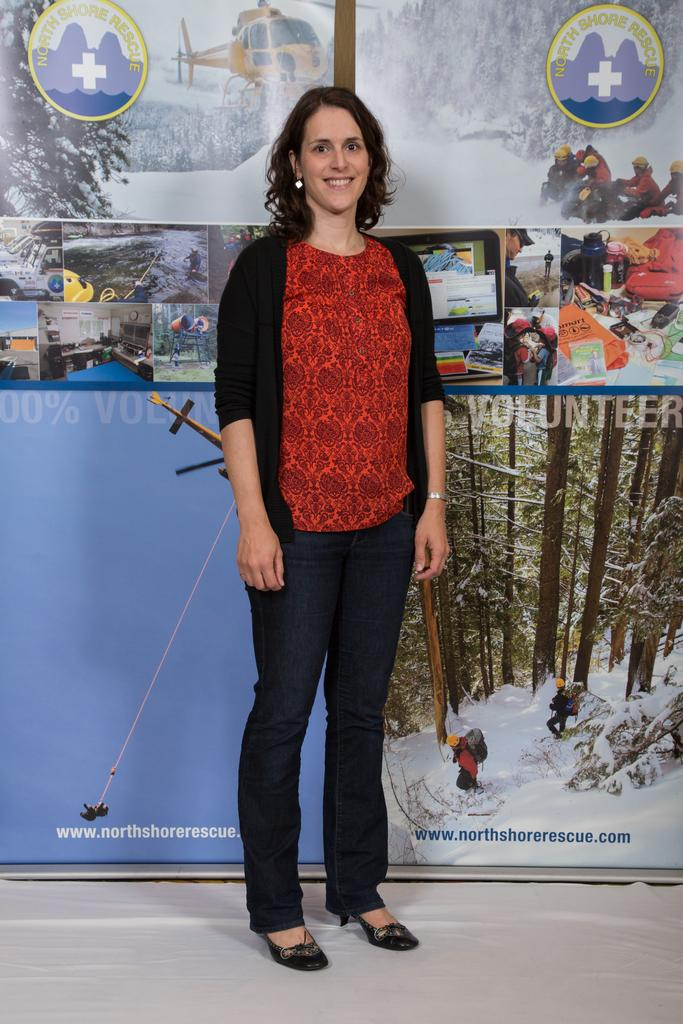What is the main subject in the foreground of the image? There is a woman standing in the foreground of the image. What is the woman standing on? The woman is standing on the ground. What can be seen in the background of the image? There is a banner, a group of people, trees, a helicopter, and the sky visible in the background of the image. What might the banner be used for? The banner could be used for advertising, promotion, or conveying information. What is the weather like in the image? The presence of a clear sky suggests good weather, but the specific season or temperature cannot be determined from the image. What type of earth can be seen in the image? There is no specific type of earth or soil visible in the image; it only shows a woman standing on the ground. What season is it in the image? The image does not provide enough information to determine the season, as the weather appears to be clear but the specific temperature or season cannot be determined. 